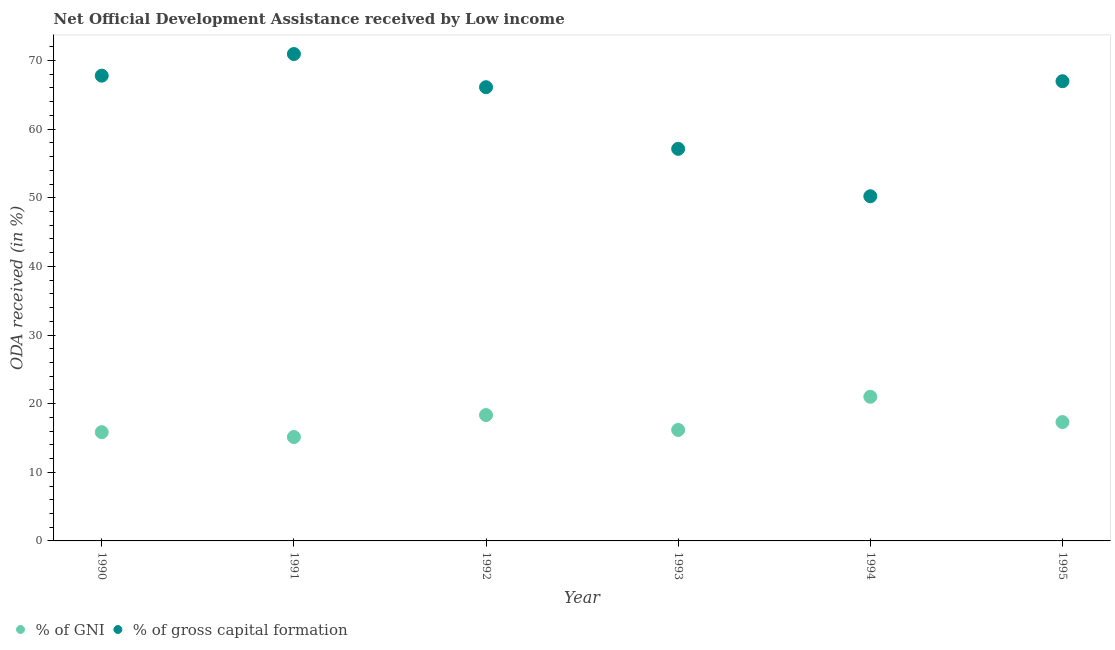Is the number of dotlines equal to the number of legend labels?
Give a very brief answer. Yes. What is the oda received as percentage of gni in 1994?
Offer a very short reply. 21.01. Across all years, what is the maximum oda received as percentage of gross capital formation?
Provide a succinct answer. 70.95. Across all years, what is the minimum oda received as percentage of gni?
Give a very brief answer. 15.14. What is the total oda received as percentage of gross capital formation in the graph?
Provide a succinct answer. 379.21. What is the difference between the oda received as percentage of gni in 1992 and that in 1995?
Ensure brevity in your answer.  1.02. What is the difference between the oda received as percentage of gni in 1992 and the oda received as percentage of gross capital formation in 1991?
Make the answer very short. -52.61. What is the average oda received as percentage of gross capital formation per year?
Provide a short and direct response. 63.2. In the year 1995, what is the difference between the oda received as percentage of gni and oda received as percentage of gross capital formation?
Your response must be concise. -49.67. What is the ratio of the oda received as percentage of gni in 1992 to that in 1995?
Provide a short and direct response. 1.06. Is the oda received as percentage of gross capital formation in 1991 less than that in 1994?
Make the answer very short. No. Is the difference between the oda received as percentage of gross capital formation in 1990 and 1991 greater than the difference between the oda received as percentage of gni in 1990 and 1991?
Give a very brief answer. No. What is the difference between the highest and the second highest oda received as percentage of gni?
Keep it short and to the point. 2.67. What is the difference between the highest and the lowest oda received as percentage of gni?
Offer a very short reply. 5.87. In how many years, is the oda received as percentage of gni greater than the average oda received as percentage of gni taken over all years?
Your response must be concise. 3. Is the sum of the oda received as percentage of gni in 1991 and 1995 greater than the maximum oda received as percentage of gross capital formation across all years?
Keep it short and to the point. No. Is the oda received as percentage of gni strictly less than the oda received as percentage of gross capital formation over the years?
Provide a short and direct response. Yes. How many dotlines are there?
Provide a short and direct response. 2. What is the difference between two consecutive major ticks on the Y-axis?
Your answer should be very brief. 10. Are the values on the major ticks of Y-axis written in scientific E-notation?
Offer a terse response. No. Does the graph contain any zero values?
Your answer should be compact. No. Does the graph contain grids?
Offer a very short reply. No. Where does the legend appear in the graph?
Your answer should be very brief. Bottom left. How are the legend labels stacked?
Give a very brief answer. Horizontal. What is the title of the graph?
Your answer should be compact. Net Official Development Assistance received by Low income. What is the label or title of the Y-axis?
Provide a succinct answer. ODA received (in %). What is the ODA received (in %) of % of GNI in 1990?
Give a very brief answer. 15.85. What is the ODA received (in %) in % of gross capital formation in 1990?
Offer a terse response. 67.8. What is the ODA received (in %) of % of GNI in 1991?
Provide a short and direct response. 15.14. What is the ODA received (in %) in % of gross capital formation in 1991?
Your answer should be compact. 70.95. What is the ODA received (in %) in % of GNI in 1992?
Offer a terse response. 18.34. What is the ODA received (in %) in % of gross capital formation in 1992?
Offer a terse response. 66.12. What is the ODA received (in %) of % of GNI in 1993?
Offer a very short reply. 16.17. What is the ODA received (in %) in % of gross capital formation in 1993?
Offer a very short reply. 57.13. What is the ODA received (in %) in % of GNI in 1994?
Your response must be concise. 21.01. What is the ODA received (in %) of % of gross capital formation in 1994?
Offer a very short reply. 50.23. What is the ODA received (in %) of % of GNI in 1995?
Your response must be concise. 17.32. What is the ODA received (in %) of % of gross capital formation in 1995?
Offer a terse response. 66.99. Across all years, what is the maximum ODA received (in %) in % of GNI?
Offer a very short reply. 21.01. Across all years, what is the maximum ODA received (in %) of % of gross capital formation?
Give a very brief answer. 70.95. Across all years, what is the minimum ODA received (in %) of % of GNI?
Your answer should be compact. 15.14. Across all years, what is the minimum ODA received (in %) in % of gross capital formation?
Your answer should be compact. 50.23. What is the total ODA received (in %) in % of GNI in the graph?
Offer a terse response. 103.82. What is the total ODA received (in %) of % of gross capital formation in the graph?
Ensure brevity in your answer.  379.21. What is the difference between the ODA received (in %) of % of GNI in 1990 and that in 1991?
Offer a very short reply. 0.71. What is the difference between the ODA received (in %) of % of gross capital formation in 1990 and that in 1991?
Provide a short and direct response. -3.15. What is the difference between the ODA received (in %) of % of GNI in 1990 and that in 1992?
Offer a very short reply. -2.49. What is the difference between the ODA received (in %) of % of gross capital formation in 1990 and that in 1992?
Offer a very short reply. 1.68. What is the difference between the ODA received (in %) in % of GNI in 1990 and that in 1993?
Provide a succinct answer. -0.33. What is the difference between the ODA received (in %) of % of gross capital formation in 1990 and that in 1993?
Offer a very short reply. 10.66. What is the difference between the ODA received (in %) in % of GNI in 1990 and that in 1994?
Ensure brevity in your answer.  -5.16. What is the difference between the ODA received (in %) in % of gross capital formation in 1990 and that in 1994?
Your response must be concise. 17.57. What is the difference between the ODA received (in %) of % of GNI in 1990 and that in 1995?
Your response must be concise. -1.47. What is the difference between the ODA received (in %) of % of gross capital formation in 1990 and that in 1995?
Your answer should be very brief. 0.81. What is the difference between the ODA received (in %) in % of GNI in 1991 and that in 1992?
Give a very brief answer. -3.2. What is the difference between the ODA received (in %) of % of gross capital formation in 1991 and that in 1992?
Offer a very short reply. 4.83. What is the difference between the ODA received (in %) in % of GNI in 1991 and that in 1993?
Make the answer very short. -1.03. What is the difference between the ODA received (in %) of % of gross capital formation in 1991 and that in 1993?
Your answer should be very brief. 13.82. What is the difference between the ODA received (in %) of % of GNI in 1991 and that in 1994?
Your response must be concise. -5.87. What is the difference between the ODA received (in %) of % of gross capital formation in 1991 and that in 1994?
Provide a succinct answer. 20.72. What is the difference between the ODA received (in %) in % of GNI in 1991 and that in 1995?
Keep it short and to the point. -2.18. What is the difference between the ODA received (in %) in % of gross capital formation in 1991 and that in 1995?
Give a very brief answer. 3.96. What is the difference between the ODA received (in %) of % of GNI in 1992 and that in 1993?
Your answer should be compact. 2.17. What is the difference between the ODA received (in %) in % of gross capital formation in 1992 and that in 1993?
Your answer should be compact. 8.98. What is the difference between the ODA received (in %) in % of GNI in 1992 and that in 1994?
Keep it short and to the point. -2.67. What is the difference between the ODA received (in %) in % of gross capital formation in 1992 and that in 1994?
Give a very brief answer. 15.89. What is the difference between the ODA received (in %) in % of GNI in 1992 and that in 1995?
Your answer should be very brief. 1.02. What is the difference between the ODA received (in %) of % of gross capital formation in 1992 and that in 1995?
Provide a succinct answer. -0.87. What is the difference between the ODA received (in %) in % of GNI in 1993 and that in 1994?
Your answer should be very brief. -4.83. What is the difference between the ODA received (in %) of % of gross capital formation in 1993 and that in 1994?
Your answer should be very brief. 6.91. What is the difference between the ODA received (in %) of % of GNI in 1993 and that in 1995?
Your answer should be very brief. -1.15. What is the difference between the ODA received (in %) of % of gross capital formation in 1993 and that in 1995?
Provide a short and direct response. -9.85. What is the difference between the ODA received (in %) of % of GNI in 1994 and that in 1995?
Your answer should be very brief. 3.69. What is the difference between the ODA received (in %) in % of gross capital formation in 1994 and that in 1995?
Your answer should be very brief. -16.76. What is the difference between the ODA received (in %) of % of GNI in 1990 and the ODA received (in %) of % of gross capital formation in 1991?
Offer a very short reply. -55.1. What is the difference between the ODA received (in %) in % of GNI in 1990 and the ODA received (in %) in % of gross capital formation in 1992?
Provide a succinct answer. -50.27. What is the difference between the ODA received (in %) in % of GNI in 1990 and the ODA received (in %) in % of gross capital formation in 1993?
Ensure brevity in your answer.  -41.29. What is the difference between the ODA received (in %) in % of GNI in 1990 and the ODA received (in %) in % of gross capital formation in 1994?
Give a very brief answer. -34.38. What is the difference between the ODA received (in %) of % of GNI in 1990 and the ODA received (in %) of % of gross capital formation in 1995?
Ensure brevity in your answer.  -51.14. What is the difference between the ODA received (in %) of % of GNI in 1991 and the ODA received (in %) of % of gross capital formation in 1992?
Give a very brief answer. -50.98. What is the difference between the ODA received (in %) in % of GNI in 1991 and the ODA received (in %) in % of gross capital formation in 1993?
Make the answer very short. -41.99. What is the difference between the ODA received (in %) in % of GNI in 1991 and the ODA received (in %) in % of gross capital formation in 1994?
Give a very brief answer. -35.09. What is the difference between the ODA received (in %) of % of GNI in 1991 and the ODA received (in %) of % of gross capital formation in 1995?
Your answer should be very brief. -51.85. What is the difference between the ODA received (in %) in % of GNI in 1992 and the ODA received (in %) in % of gross capital formation in 1993?
Provide a short and direct response. -38.8. What is the difference between the ODA received (in %) of % of GNI in 1992 and the ODA received (in %) of % of gross capital formation in 1994?
Your answer should be compact. -31.89. What is the difference between the ODA received (in %) of % of GNI in 1992 and the ODA received (in %) of % of gross capital formation in 1995?
Provide a short and direct response. -48.65. What is the difference between the ODA received (in %) of % of GNI in 1993 and the ODA received (in %) of % of gross capital formation in 1994?
Your answer should be compact. -34.05. What is the difference between the ODA received (in %) in % of GNI in 1993 and the ODA received (in %) in % of gross capital formation in 1995?
Give a very brief answer. -50.81. What is the difference between the ODA received (in %) in % of GNI in 1994 and the ODA received (in %) in % of gross capital formation in 1995?
Make the answer very short. -45.98. What is the average ODA received (in %) in % of GNI per year?
Ensure brevity in your answer.  17.3. What is the average ODA received (in %) in % of gross capital formation per year?
Your answer should be compact. 63.2. In the year 1990, what is the difference between the ODA received (in %) of % of GNI and ODA received (in %) of % of gross capital formation?
Your answer should be very brief. -51.95. In the year 1991, what is the difference between the ODA received (in %) in % of GNI and ODA received (in %) in % of gross capital formation?
Your answer should be very brief. -55.81. In the year 1992, what is the difference between the ODA received (in %) in % of GNI and ODA received (in %) in % of gross capital formation?
Provide a succinct answer. -47.78. In the year 1993, what is the difference between the ODA received (in %) of % of GNI and ODA received (in %) of % of gross capital formation?
Ensure brevity in your answer.  -40.96. In the year 1994, what is the difference between the ODA received (in %) in % of GNI and ODA received (in %) in % of gross capital formation?
Make the answer very short. -29.22. In the year 1995, what is the difference between the ODA received (in %) of % of GNI and ODA received (in %) of % of gross capital formation?
Provide a short and direct response. -49.67. What is the ratio of the ODA received (in %) of % of GNI in 1990 to that in 1991?
Offer a very short reply. 1.05. What is the ratio of the ODA received (in %) of % of gross capital formation in 1990 to that in 1991?
Keep it short and to the point. 0.96. What is the ratio of the ODA received (in %) of % of GNI in 1990 to that in 1992?
Provide a succinct answer. 0.86. What is the ratio of the ODA received (in %) in % of gross capital formation in 1990 to that in 1992?
Your answer should be very brief. 1.03. What is the ratio of the ODA received (in %) in % of GNI in 1990 to that in 1993?
Give a very brief answer. 0.98. What is the ratio of the ODA received (in %) in % of gross capital formation in 1990 to that in 1993?
Provide a succinct answer. 1.19. What is the ratio of the ODA received (in %) in % of GNI in 1990 to that in 1994?
Provide a short and direct response. 0.75. What is the ratio of the ODA received (in %) in % of gross capital formation in 1990 to that in 1994?
Your answer should be very brief. 1.35. What is the ratio of the ODA received (in %) of % of GNI in 1990 to that in 1995?
Provide a short and direct response. 0.92. What is the ratio of the ODA received (in %) of % of gross capital formation in 1990 to that in 1995?
Offer a very short reply. 1.01. What is the ratio of the ODA received (in %) in % of GNI in 1991 to that in 1992?
Your answer should be compact. 0.83. What is the ratio of the ODA received (in %) of % of gross capital formation in 1991 to that in 1992?
Offer a very short reply. 1.07. What is the ratio of the ODA received (in %) in % of GNI in 1991 to that in 1993?
Keep it short and to the point. 0.94. What is the ratio of the ODA received (in %) in % of gross capital formation in 1991 to that in 1993?
Provide a succinct answer. 1.24. What is the ratio of the ODA received (in %) of % of GNI in 1991 to that in 1994?
Offer a very short reply. 0.72. What is the ratio of the ODA received (in %) of % of gross capital formation in 1991 to that in 1994?
Offer a terse response. 1.41. What is the ratio of the ODA received (in %) of % of GNI in 1991 to that in 1995?
Your answer should be very brief. 0.87. What is the ratio of the ODA received (in %) of % of gross capital formation in 1991 to that in 1995?
Ensure brevity in your answer.  1.06. What is the ratio of the ODA received (in %) in % of GNI in 1992 to that in 1993?
Provide a succinct answer. 1.13. What is the ratio of the ODA received (in %) of % of gross capital formation in 1992 to that in 1993?
Your answer should be very brief. 1.16. What is the ratio of the ODA received (in %) in % of GNI in 1992 to that in 1994?
Provide a short and direct response. 0.87. What is the ratio of the ODA received (in %) in % of gross capital formation in 1992 to that in 1994?
Offer a very short reply. 1.32. What is the ratio of the ODA received (in %) in % of GNI in 1992 to that in 1995?
Make the answer very short. 1.06. What is the ratio of the ODA received (in %) in % of gross capital formation in 1992 to that in 1995?
Your answer should be very brief. 0.99. What is the ratio of the ODA received (in %) in % of GNI in 1993 to that in 1994?
Ensure brevity in your answer.  0.77. What is the ratio of the ODA received (in %) in % of gross capital formation in 1993 to that in 1994?
Keep it short and to the point. 1.14. What is the ratio of the ODA received (in %) in % of GNI in 1993 to that in 1995?
Keep it short and to the point. 0.93. What is the ratio of the ODA received (in %) of % of gross capital formation in 1993 to that in 1995?
Your answer should be compact. 0.85. What is the ratio of the ODA received (in %) of % of GNI in 1994 to that in 1995?
Offer a very short reply. 1.21. What is the ratio of the ODA received (in %) of % of gross capital formation in 1994 to that in 1995?
Your answer should be compact. 0.75. What is the difference between the highest and the second highest ODA received (in %) in % of GNI?
Give a very brief answer. 2.67. What is the difference between the highest and the second highest ODA received (in %) in % of gross capital formation?
Offer a very short reply. 3.15. What is the difference between the highest and the lowest ODA received (in %) in % of GNI?
Your answer should be compact. 5.87. What is the difference between the highest and the lowest ODA received (in %) of % of gross capital formation?
Make the answer very short. 20.72. 